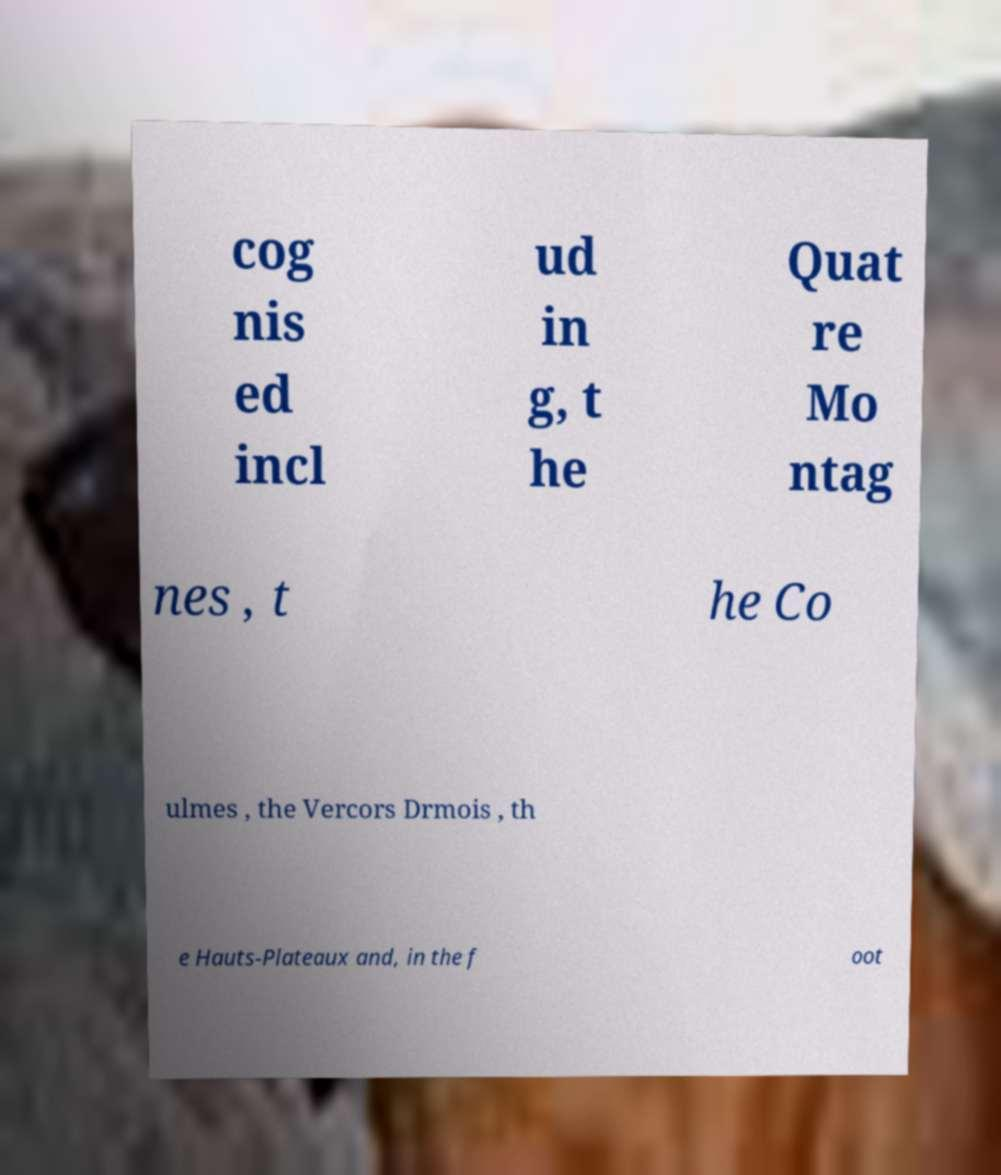There's text embedded in this image that I need extracted. Can you transcribe it verbatim? cog nis ed incl ud in g, t he Quat re Mo ntag nes , t he Co ulmes , the Vercors Drmois , th e Hauts-Plateaux and, in the f oot 